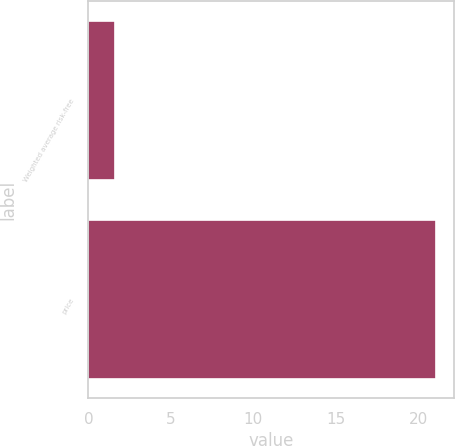Convert chart to OTSL. <chart><loc_0><loc_0><loc_500><loc_500><bar_chart><fcel>Weighted average risk-free<fcel>price<nl><fcel>1.61<fcel>21.09<nl></chart> 